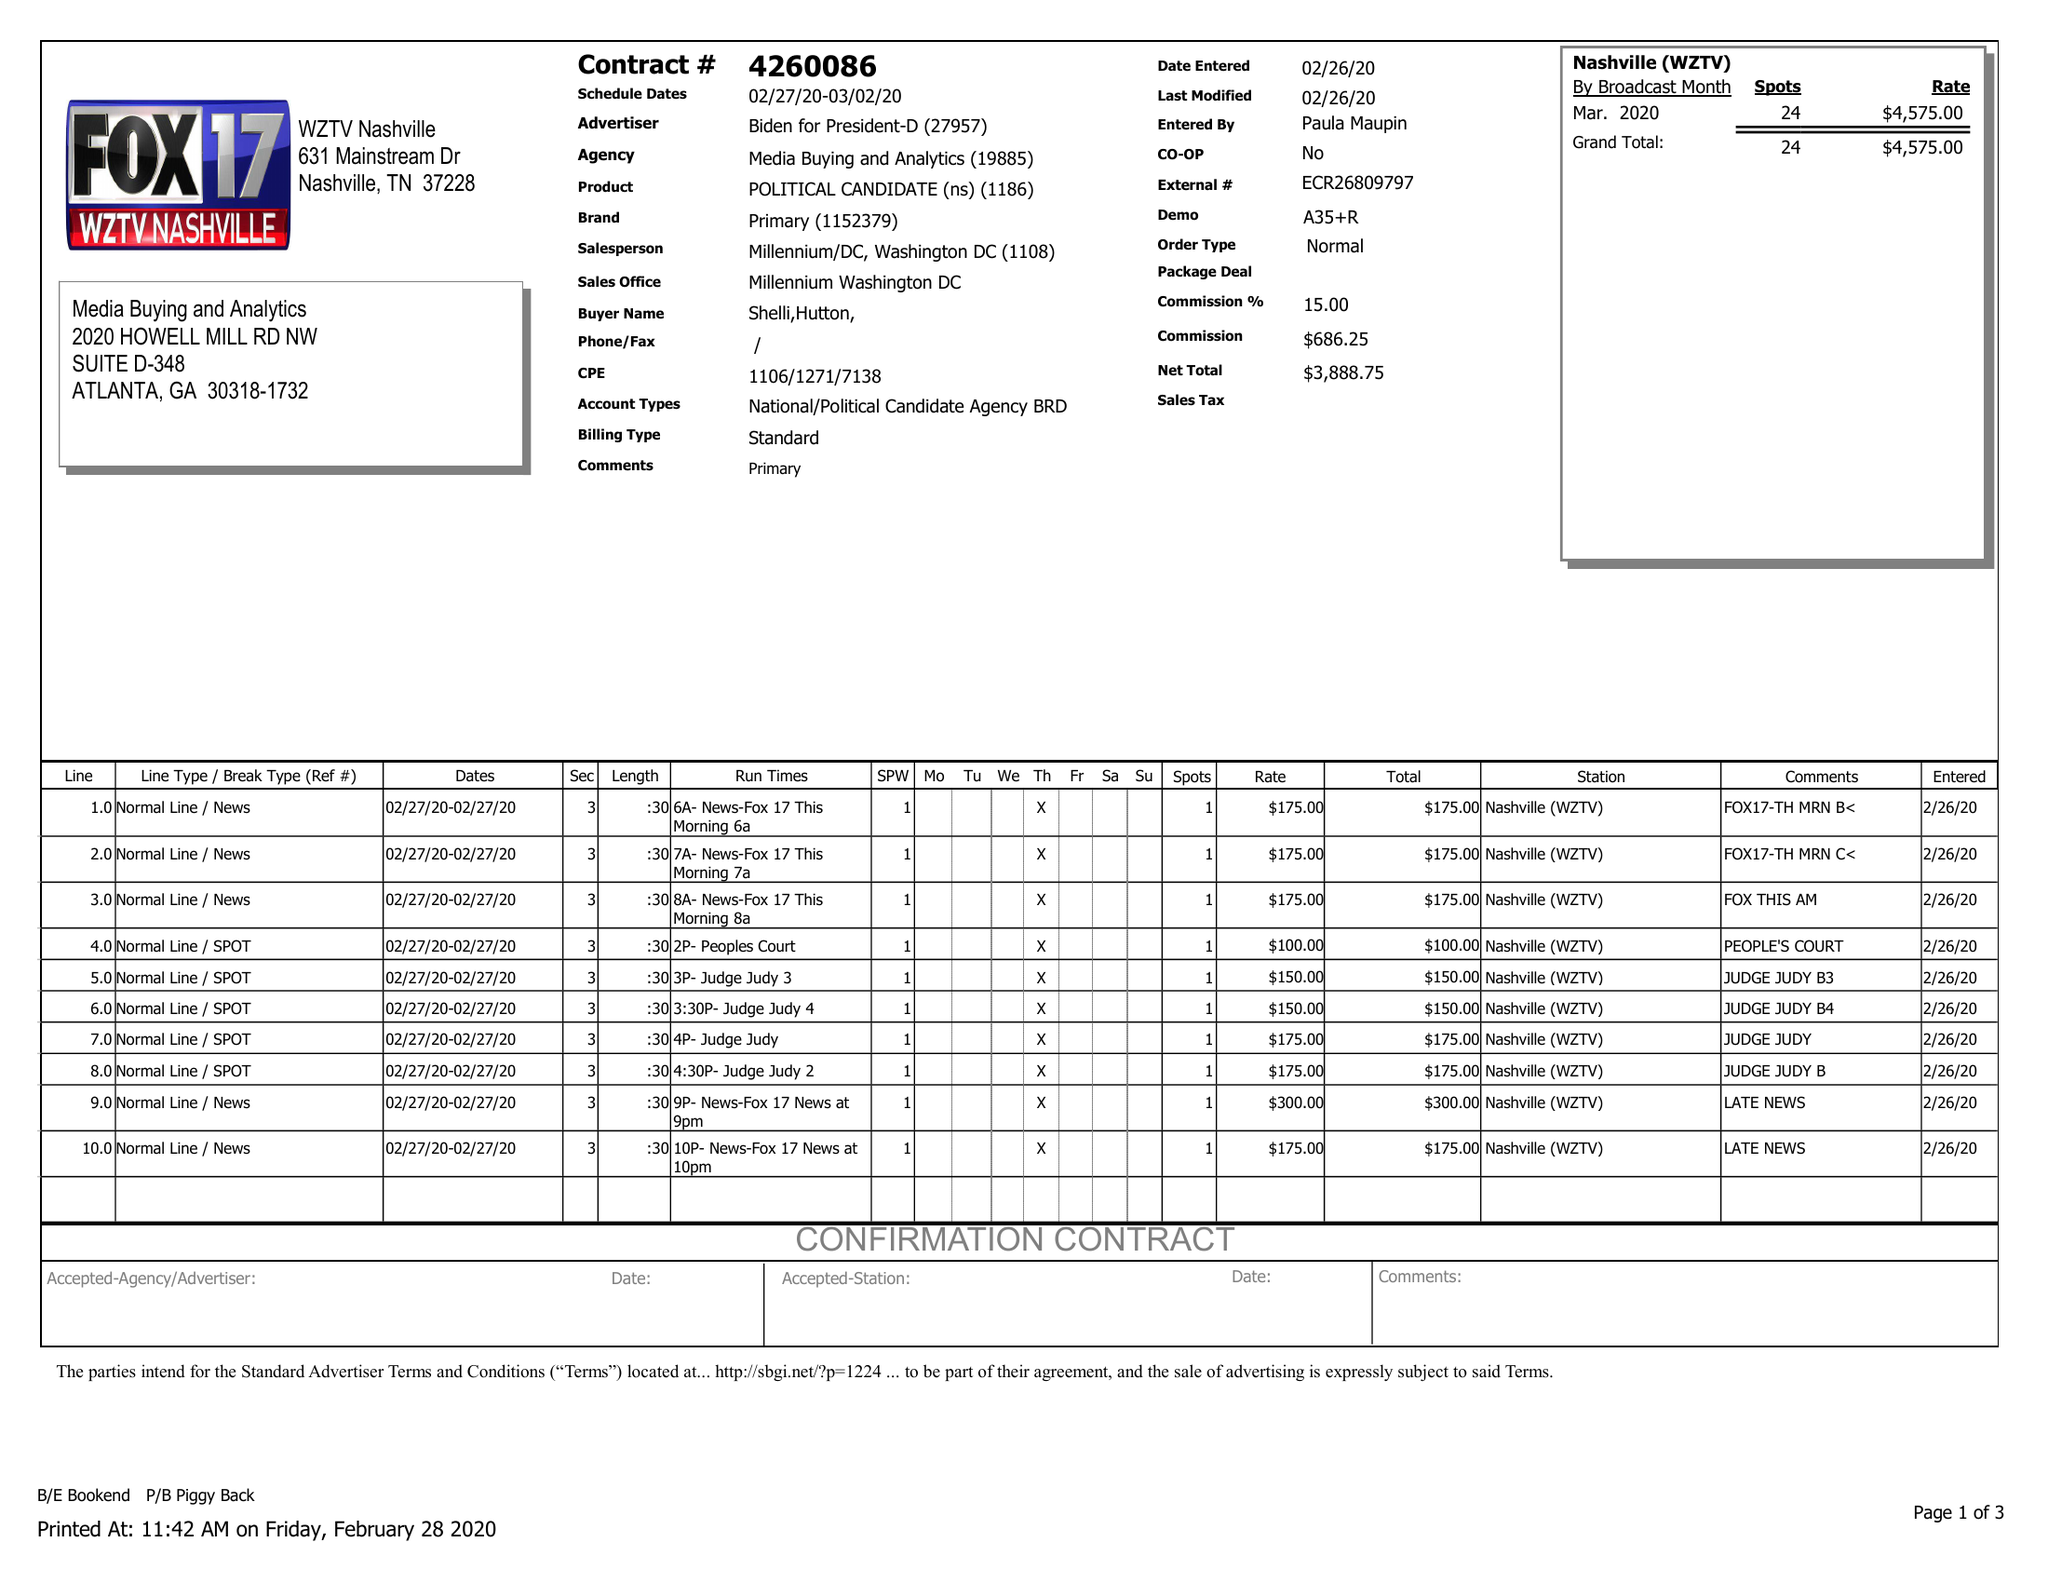What is the value for the flight_to?
Answer the question using a single word or phrase. 03/02/20 